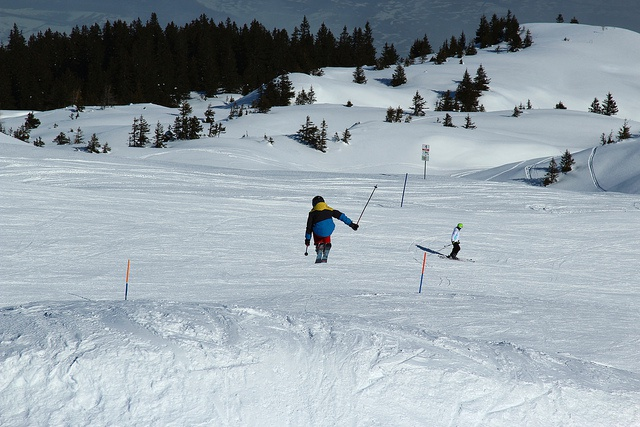Describe the objects in this image and their specific colors. I can see people in blue, black, navy, and gray tones, people in blue, black, lavender, and darkgray tones, and skis in blue, black, and gray tones in this image. 